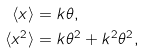<formula> <loc_0><loc_0><loc_500><loc_500>\langle x \rangle & = k \theta , \\ \langle x ^ { 2 } \rangle & = k \theta ^ { 2 } + k ^ { 2 } \theta ^ { 2 } ,</formula> 